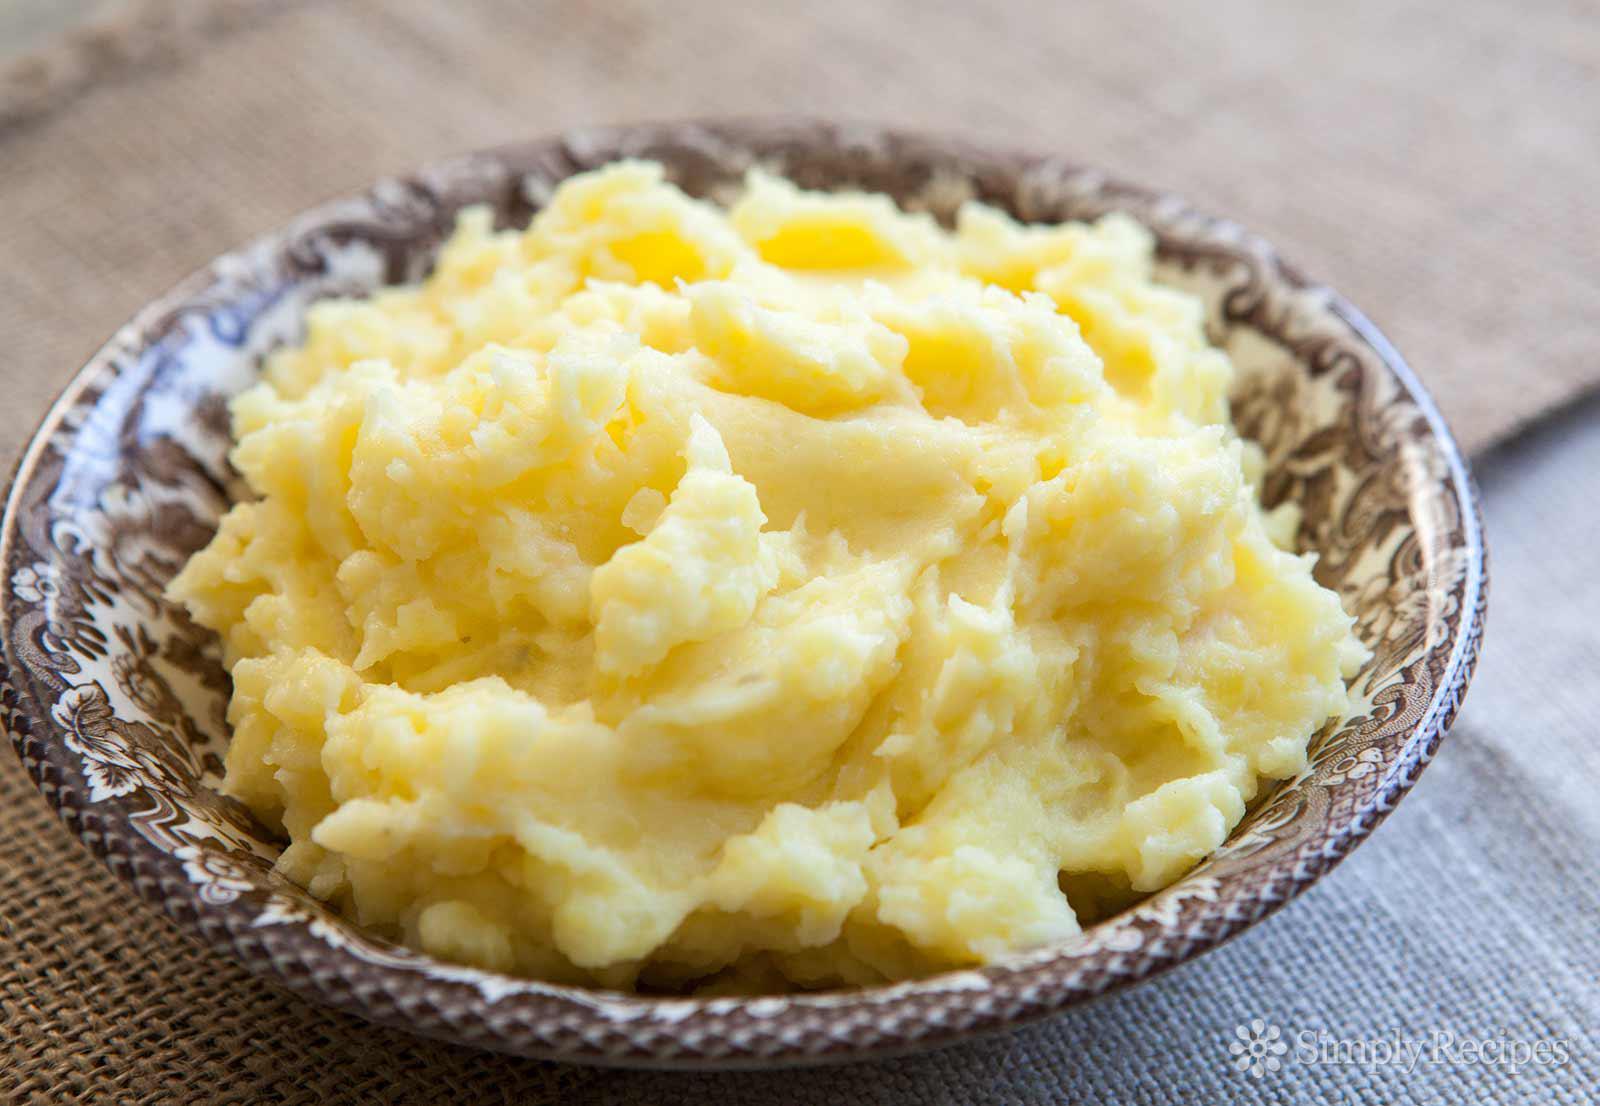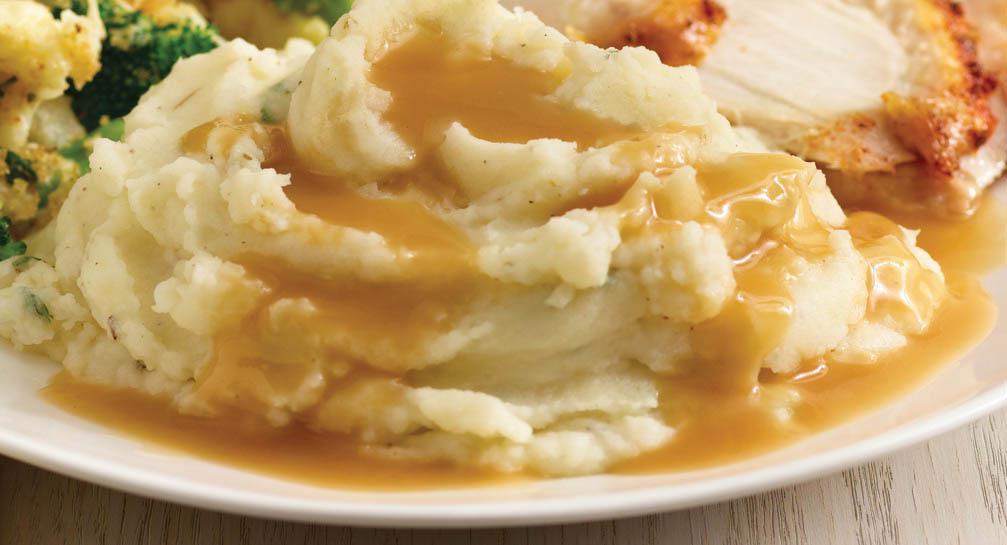The first image is the image on the left, the second image is the image on the right. Given the left and right images, does the statement "Oily butter is melting on at least one of the dishes." hold true? Answer yes or no. No. 